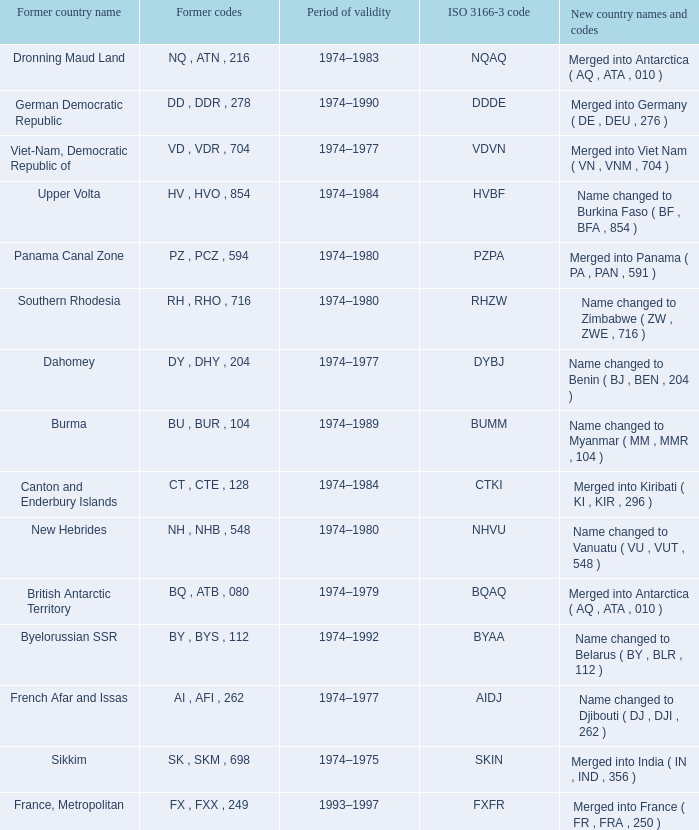Name the former codes for  merged into panama ( pa , pan , 591 ) PZ , PCZ , 594. 